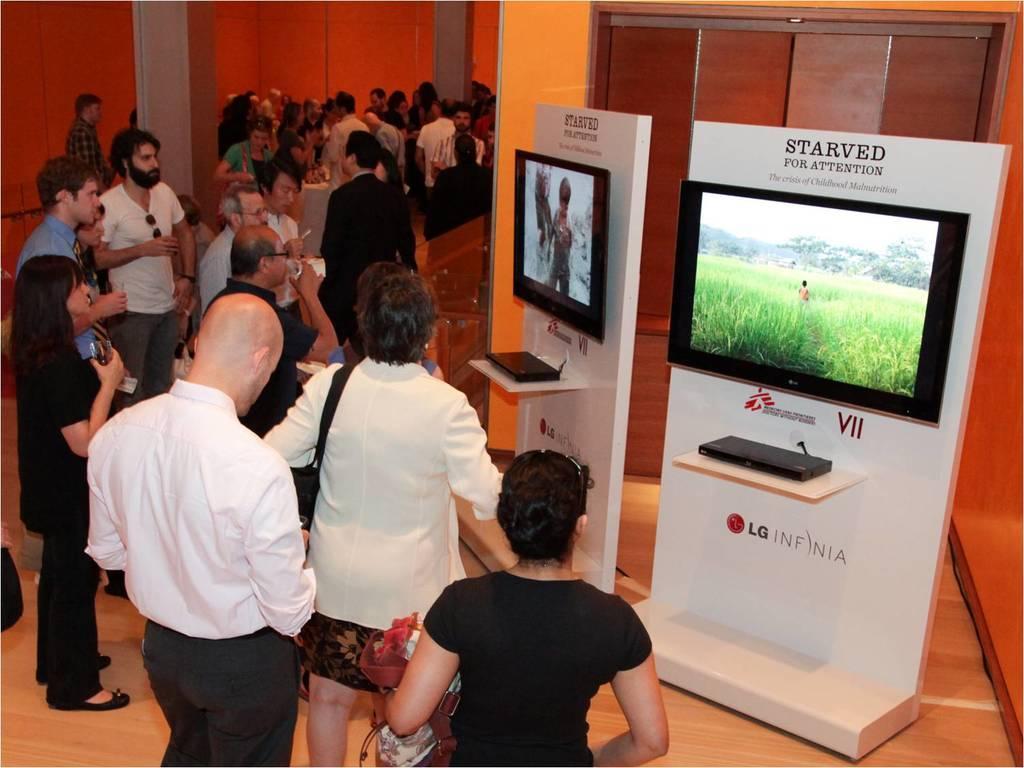In one or two sentences, can you explain what this image depicts? In this image we can see a group of persons and among them few people are holding objects. On the right side, we can see the boards. On the boards we can see the electronic gadgets. Behind the persons we can see the wall and pillars. 